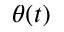<formula> <loc_0><loc_0><loc_500><loc_500>\theta ( t )</formula> 